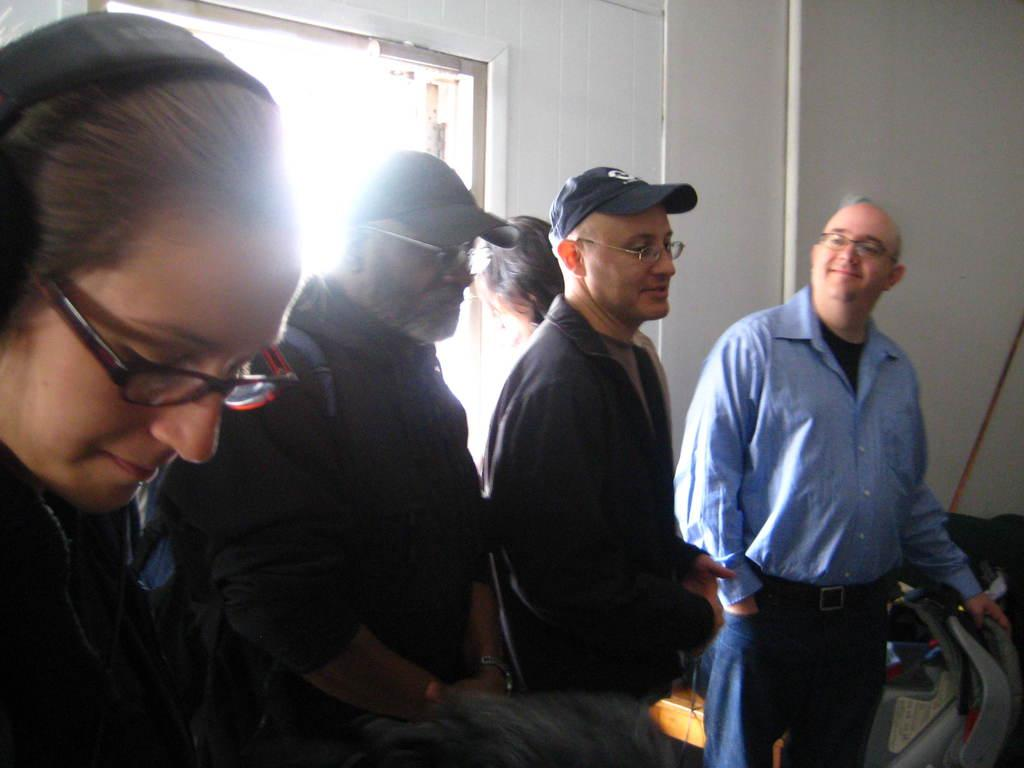What is happening in the image involving people? There is a group of people standing in the image. What can be seen on the right side of the image? There are objects on the right side of the image. What is visible in the background of the image? There is a window and walls visible in the background of the image. What type of cheese is being used to build a sandcastle in the image? There is no cheese or sandcastle present in the image. Can you see a rabbit hopping near the group of people in the image? There is no rabbit visible in the image. 